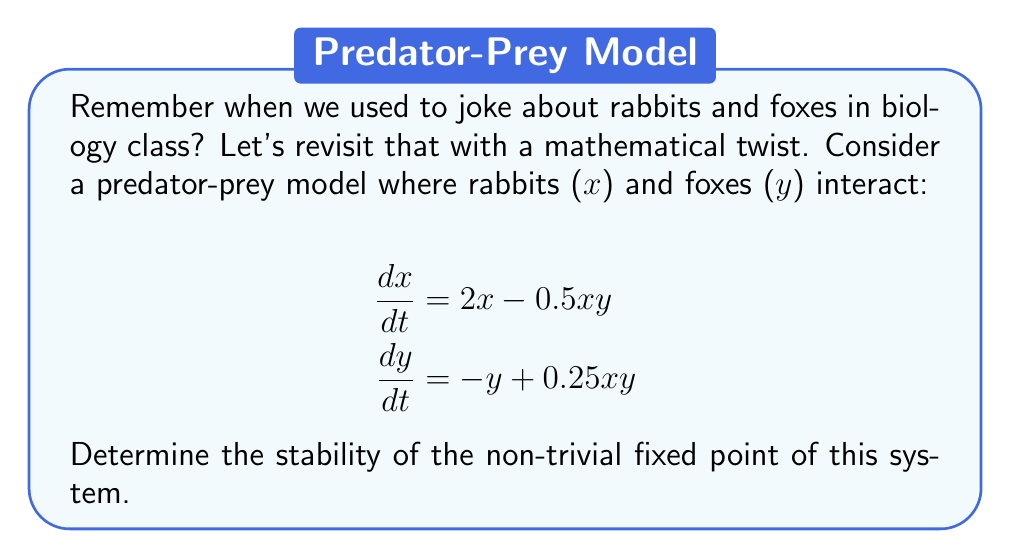Teach me how to tackle this problem. 1) First, let's find the fixed points by setting both equations to zero:

   $$2x - 0.5xy = 0$$
   $$-y + 0.25xy = 0$$

2) From the first equation:
   $$x(2 - 0.5y) = 0$$
   So either $x = 0$ or $y = 4$

3) From the second equation:
   $$y(-1 + 0.25x) = 0$$
   So either $y = 0$ or $x = 4$

4) The non-trivial fixed point is $(x^*, y^*) = (4, 4)$

5) To determine stability, we need to find the Jacobian matrix:

   $$J = \begin{bmatrix}
   \frac{\partial f_1}{\partial x} & \frac{\partial f_1}{\partial y} \\
   \frac{\partial f_2}{\partial x} & \frac{\partial f_2}{\partial y}
   \end{bmatrix} = \begin{bmatrix}
   2 - 0.5y & -0.5x \\
   0.25y & -1 + 0.25x
   \end{bmatrix}$$

6) Evaluate the Jacobian at the fixed point (4, 4):

   $$J(4,4) = \begin{bmatrix}
   0 & -2 \\
   1 & 0
   \end{bmatrix}$$

7) Calculate the eigenvalues:
   $$\det(J - \lambda I) = \begin{vmatrix}
   -\lambda & -2 \\
   1 & -\lambda
   \end{vmatrix} = \lambda^2 + 2 = 0$$

8) Solve for $\lambda$:
   $$\lambda = \pm i\sqrt{2}$$

9) Since the real parts of both eigenvalues are zero, this fixed point is a center.
Answer: Center (neutrally stable) 